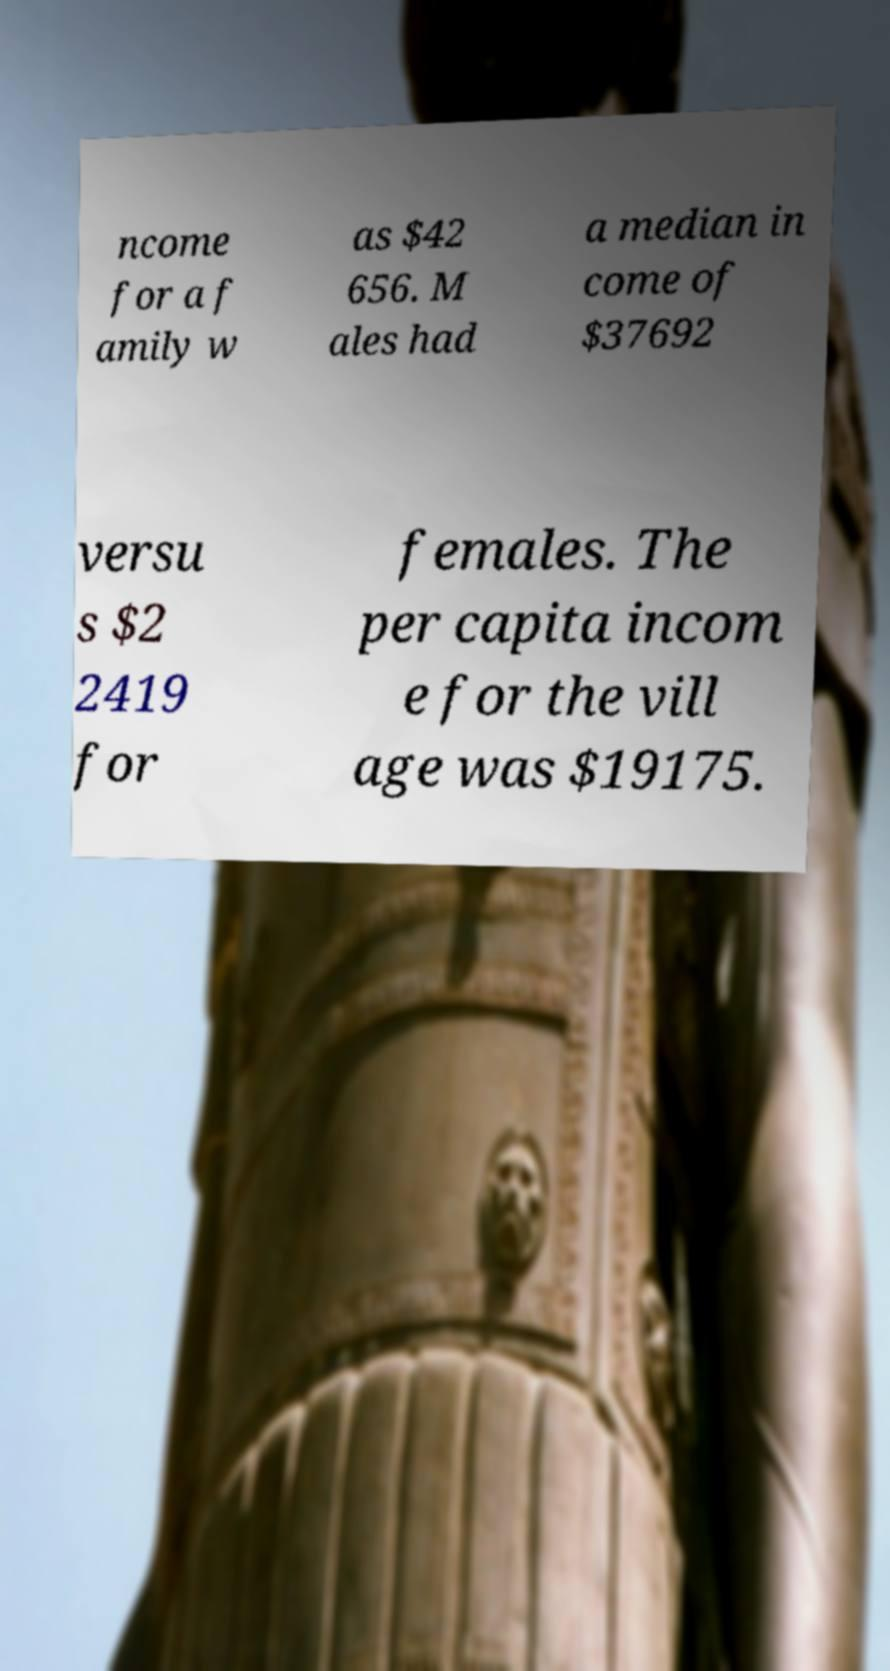Could you assist in decoding the text presented in this image and type it out clearly? ncome for a f amily w as $42 656. M ales had a median in come of $37692 versu s $2 2419 for females. The per capita incom e for the vill age was $19175. 